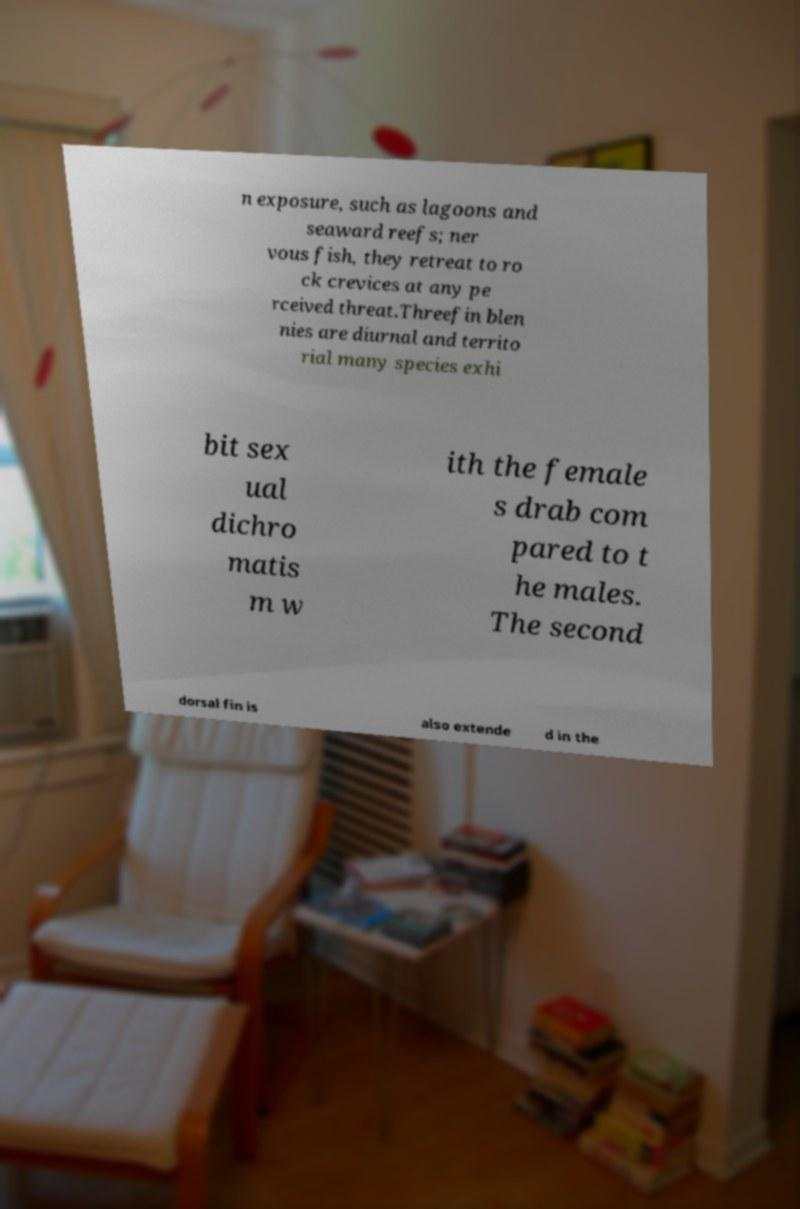Can you read and provide the text displayed in the image?This photo seems to have some interesting text. Can you extract and type it out for me? n exposure, such as lagoons and seaward reefs; ner vous fish, they retreat to ro ck crevices at any pe rceived threat.Threefin blen nies are diurnal and territo rial many species exhi bit sex ual dichro matis m w ith the female s drab com pared to t he males. The second dorsal fin is also extende d in the 